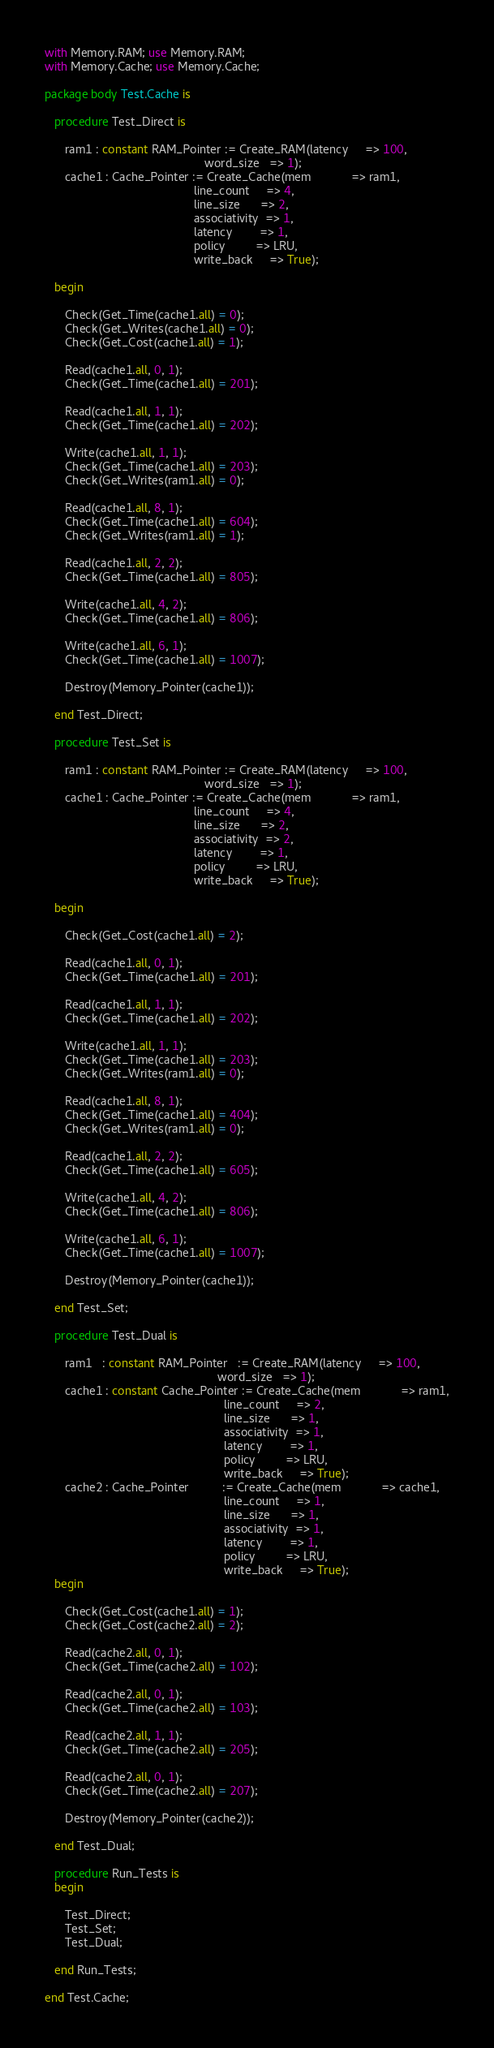Convert code to text. <code><loc_0><loc_0><loc_500><loc_500><_Ada_>
with Memory.RAM; use Memory.RAM;
with Memory.Cache; use Memory.Cache;

package body Test.Cache is

   procedure Test_Direct is

      ram1 : constant RAM_Pointer := Create_RAM(latency     => 100,
                                                word_size   => 1);
      cache1 : Cache_Pointer := Create_Cache(mem            => ram1,
                                             line_count     => 4,
                                             line_size      => 2,
                                             associativity  => 1,
                                             latency        => 1,
                                             policy         => LRU,
                                             write_back     => True);

   begin

      Check(Get_Time(cache1.all) = 0);
      Check(Get_Writes(cache1.all) = 0);
      Check(Get_Cost(cache1.all) = 1);

      Read(cache1.all, 0, 1);
      Check(Get_Time(cache1.all) = 201);

      Read(cache1.all, 1, 1);
      Check(Get_Time(cache1.all) = 202);

      Write(cache1.all, 1, 1);
      Check(Get_Time(cache1.all) = 203);
      Check(Get_Writes(ram1.all) = 0);

      Read(cache1.all, 8, 1);
      Check(Get_Time(cache1.all) = 604);
      Check(Get_Writes(ram1.all) = 1);

      Read(cache1.all, 2, 2);
      Check(Get_Time(cache1.all) = 805);

      Write(cache1.all, 4, 2);
      Check(Get_Time(cache1.all) = 806);

      Write(cache1.all, 6, 1);
      Check(Get_Time(cache1.all) = 1007);

      Destroy(Memory_Pointer(cache1));

   end Test_Direct;

   procedure Test_Set is

      ram1 : constant RAM_Pointer := Create_RAM(latency     => 100,
                                                word_size   => 1);
      cache1 : Cache_Pointer := Create_Cache(mem            => ram1,
                                             line_count     => 4,
                                             line_size      => 2,
                                             associativity  => 2,
                                             latency        => 1,
                                             policy         => LRU,
                                             write_back     => True);

   begin

      Check(Get_Cost(cache1.all) = 2);

      Read(cache1.all, 0, 1);
      Check(Get_Time(cache1.all) = 201);

      Read(cache1.all, 1, 1);
      Check(Get_Time(cache1.all) = 202);

      Write(cache1.all, 1, 1);
      Check(Get_Time(cache1.all) = 203);
      Check(Get_Writes(ram1.all) = 0);

      Read(cache1.all, 8, 1);
      Check(Get_Time(cache1.all) = 404);
      Check(Get_Writes(ram1.all) = 0);

      Read(cache1.all, 2, 2);
      Check(Get_Time(cache1.all) = 605);

      Write(cache1.all, 4, 2);
      Check(Get_Time(cache1.all) = 806);

      Write(cache1.all, 6, 1);
      Check(Get_Time(cache1.all) = 1007);

      Destroy(Memory_Pointer(cache1));

   end Test_Set;

   procedure Test_Dual is

      ram1   : constant RAM_Pointer   := Create_RAM(latency     => 100,
                                                    word_size   => 1);
      cache1 : constant Cache_Pointer := Create_Cache(mem            => ram1,
                                                      line_count     => 2,
                                                      line_size      => 1,
                                                      associativity  => 1,
                                                      latency        => 1,
                                                      policy         => LRU,
                                                      write_back     => True);
      cache2 : Cache_Pointer          := Create_Cache(mem            => cache1,
                                                      line_count     => 1,
                                                      line_size      => 1,
                                                      associativity  => 1,
                                                      latency        => 1,
                                                      policy         => LRU,
                                                      write_back     => True);
   begin

      Check(Get_Cost(cache1.all) = 1);
      Check(Get_Cost(cache2.all) = 2);

      Read(cache2.all, 0, 1);
      Check(Get_Time(cache2.all) = 102);

      Read(cache2.all, 0, 1);
      Check(Get_Time(cache2.all) = 103);

      Read(cache2.all, 1, 1);
      Check(Get_Time(cache2.all) = 205);

      Read(cache2.all, 0, 1);
      Check(Get_Time(cache2.all) = 207);

      Destroy(Memory_Pointer(cache2));

   end Test_Dual;

   procedure Run_Tests is
   begin

      Test_Direct;
      Test_Set;
      Test_Dual;

   end Run_Tests;

end Test.Cache;
</code> 